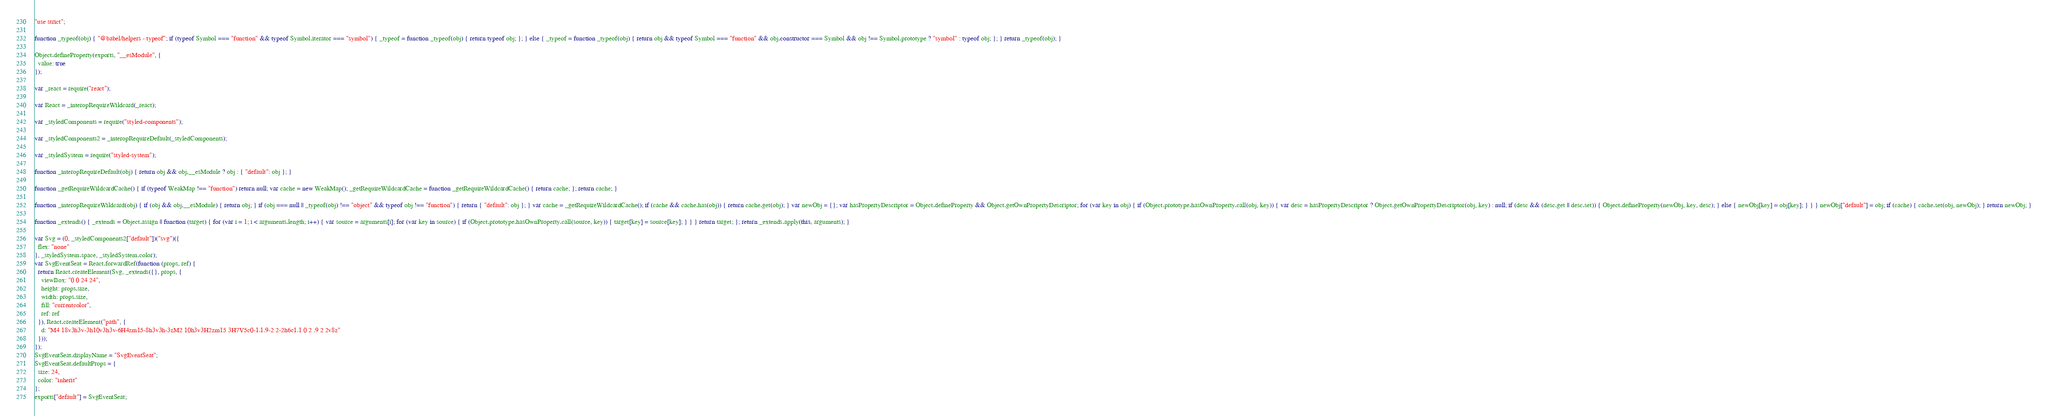Convert code to text. <code><loc_0><loc_0><loc_500><loc_500><_JavaScript_>"use strict";

function _typeof(obj) { "@babel/helpers - typeof"; if (typeof Symbol === "function" && typeof Symbol.iterator === "symbol") { _typeof = function _typeof(obj) { return typeof obj; }; } else { _typeof = function _typeof(obj) { return obj && typeof Symbol === "function" && obj.constructor === Symbol && obj !== Symbol.prototype ? "symbol" : typeof obj; }; } return _typeof(obj); }

Object.defineProperty(exports, "__esModule", {
  value: true
});

var _react = require("react");

var React = _interopRequireWildcard(_react);

var _styledComponents = require("styled-components");

var _styledComponents2 = _interopRequireDefault(_styledComponents);

var _styledSystem = require("styled-system");

function _interopRequireDefault(obj) { return obj && obj.__esModule ? obj : { "default": obj }; }

function _getRequireWildcardCache() { if (typeof WeakMap !== "function") return null; var cache = new WeakMap(); _getRequireWildcardCache = function _getRequireWildcardCache() { return cache; }; return cache; }

function _interopRequireWildcard(obj) { if (obj && obj.__esModule) { return obj; } if (obj === null || _typeof(obj) !== "object" && typeof obj !== "function") { return { "default": obj }; } var cache = _getRequireWildcardCache(); if (cache && cache.has(obj)) { return cache.get(obj); } var newObj = {}; var hasPropertyDescriptor = Object.defineProperty && Object.getOwnPropertyDescriptor; for (var key in obj) { if (Object.prototype.hasOwnProperty.call(obj, key)) { var desc = hasPropertyDescriptor ? Object.getOwnPropertyDescriptor(obj, key) : null; if (desc && (desc.get || desc.set)) { Object.defineProperty(newObj, key, desc); } else { newObj[key] = obj[key]; } } } newObj["default"] = obj; if (cache) { cache.set(obj, newObj); } return newObj; }

function _extends() { _extends = Object.assign || function (target) { for (var i = 1; i < arguments.length; i++) { var source = arguments[i]; for (var key in source) { if (Object.prototype.hasOwnProperty.call(source, key)) { target[key] = source[key]; } } } return target; }; return _extends.apply(this, arguments); }

var Svg = (0, _styledComponents2["default"])("svg")({
  flex: "none"
}, _styledSystem.space, _styledSystem.color);
var SvgEventSeat = React.forwardRef(function (props, ref) {
  return React.createElement(Svg, _extends({}, props, {
    viewBox: "0 0 24 24",
    height: props.size,
    width: props.size,
    fill: "currentcolor",
    ref: ref
  }), React.createElement("path", {
    d: "M4 18v3h3v-3h10v3h3v-6H4zm15-8h3v3h-3zM2 10h3v3H2zm15 3H7V5c0-1.1.9-2 2-2h6c1.1 0 2 .9 2 2v8z"
  }));
});
SvgEventSeat.displayName = "SvgEventSeat";
SvgEventSeat.defaultProps = {
  size: 24,
  color: "inherit"
};
exports["default"] = SvgEventSeat;</code> 